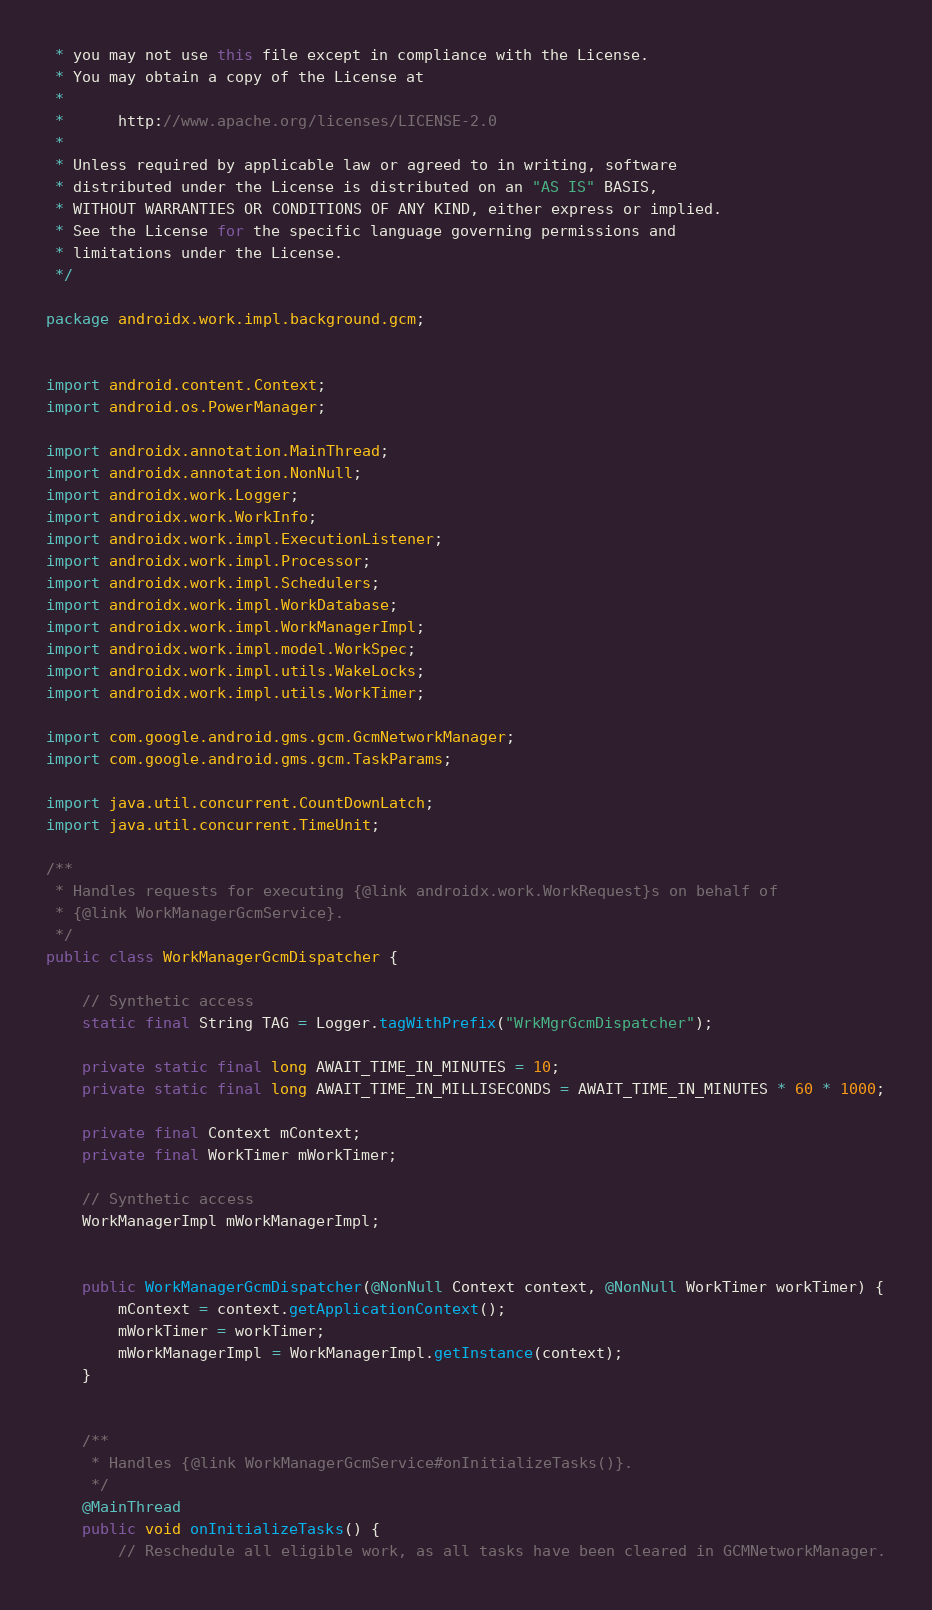Convert code to text. <code><loc_0><loc_0><loc_500><loc_500><_Java_> * you may not use this file except in compliance with the License.
 * You may obtain a copy of the License at
 *
 *      http://www.apache.org/licenses/LICENSE-2.0
 *
 * Unless required by applicable law or agreed to in writing, software
 * distributed under the License is distributed on an "AS IS" BASIS,
 * WITHOUT WARRANTIES OR CONDITIONS OF ANY KIND, either express or implied.
 * See the License for the specific language governing permissions and
 * limitations under the License.
 */

package androidx.work.impl.background.gcm;


import android.content.Context;
import android.os.PowerManager;

import androidx.annotation.MainThread;
import androidx.annotation.NonNull;
import androidx.work.Logger;
import androidx.work.WorkInfo;
import androidx.work.impl.ExecutionListener;
import androidx.work.impl.Processor;
import androidx.work.impl.Schedulers;
import androidx.work.impl.WorkDatabase;
import androidx.work.impl.WorkManagerImpl;
import androidx.work.impl.model.WorkSpec;
import androidx.work.impl.utils.WakeLocks;
import androidx.work.impl.utils.WorkTimer;

import com.google.android.gms.gcm.GcmNetworkManager;
import com.google.android.gms.gcm.TaskParams;

import java.util.concurrent.CountDownLatch;
import java.util.concurrent.TimeUnit;

/**
 * Handles requests for executing {@link androidx.work.WorkRequest}s on behalf of
 * {@link WorkManagerGcmService}.
 */
public class WorkManagerGcmDispatcher {

    // Synthetic access
    static final String TAG = Logger.tagWithPrefix("WrkMgrGcmDispatcher");

    private static final long AWAIT_TIME_IN_MINUTES = 10;
    private static final long AWAIT_TIME_IN_MILLISECONDS = AWAIT_TIME_IN_MINUTES * 60 * 1000;

    private final Context mContext;
    private final WorkTimer mWorkTimer;

    // Synthetic access
    WorkManagerImpl mWorkManagerImpl;


    public WorkManagerGcmDispatcher(@NonNull Context context, @NonNull WorkTimer workTimer) {
        mContext = context.getApplicationContext();
        mWorkTimer = workTimer;
        mWorkManagerImpl = WorkManagerImpl.getInstance(context);
    }


    /**
     * Handles {@link WorkManagerGcmService#onInitializeTasks()}.
     */
    @MainThread
    public void onInitializeTasks() {
        // Reschedule all eligible work, as all tasks have been cleared in GCMNetworkManager.</code> 